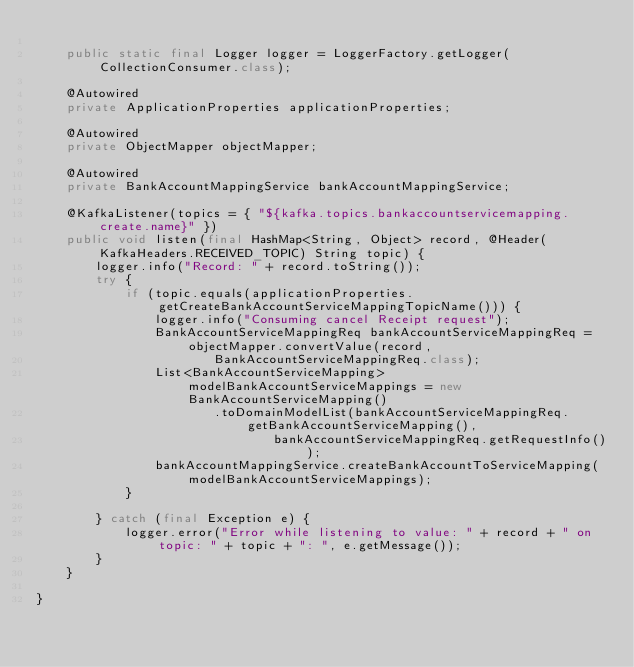<code> <loc_0><loc_0><loc_500><loc_500><_Java_>
    public static final Logger logger = LoggerFactory.getLogger(CollectionConsumer.class);

    @Autowired
    private ApplicationProperties applicationProperties;

    @Autowired
    private ObjectMapper objectMapper;

    @Autowired
    private BankAccountMappingService bankAccountMappingService;

    @KafkaListener(topics = { "${kafka.topics.bankaccountservicemapping.create.name}" })
    public void listen(final HashMap<String, Object> record, @Header(KafkaHeaders.RECEIVED_TOPIC) String topic) {
        logger.info("Record: " + record.toString());
        try {
            if (topic.equals(applicationProperties.getCreateBankAccountServiceMappingTopicName())) {
                logger.info("Consuming cancel Receipt request");
                BankAccountServiceMappingReq bankAccountServiceMappingReq = objectMapper.convertValue(record,
                        BankAccountServiceMappingReq.class);
                List<BankAccountServiceMapping> modelBankAccountServiceMappings = new BankAccountServiceMapping()
                        .toDomainModelList(bankAccountServiceMappingReq.getBankAccountServiceMapping(),
                                bankAccountServiceMappingReq.getRequestInfo());
                bankAccountMappingService.createBankAccountToServiceMapping(modelBankAccountServiceMappings);
            }

        } catch (final Exception e) {
            logger.error("Error while listening to value: " + record + " on topic: " + topic + ": ", e.getMessage());
        }
    }

}</code> 